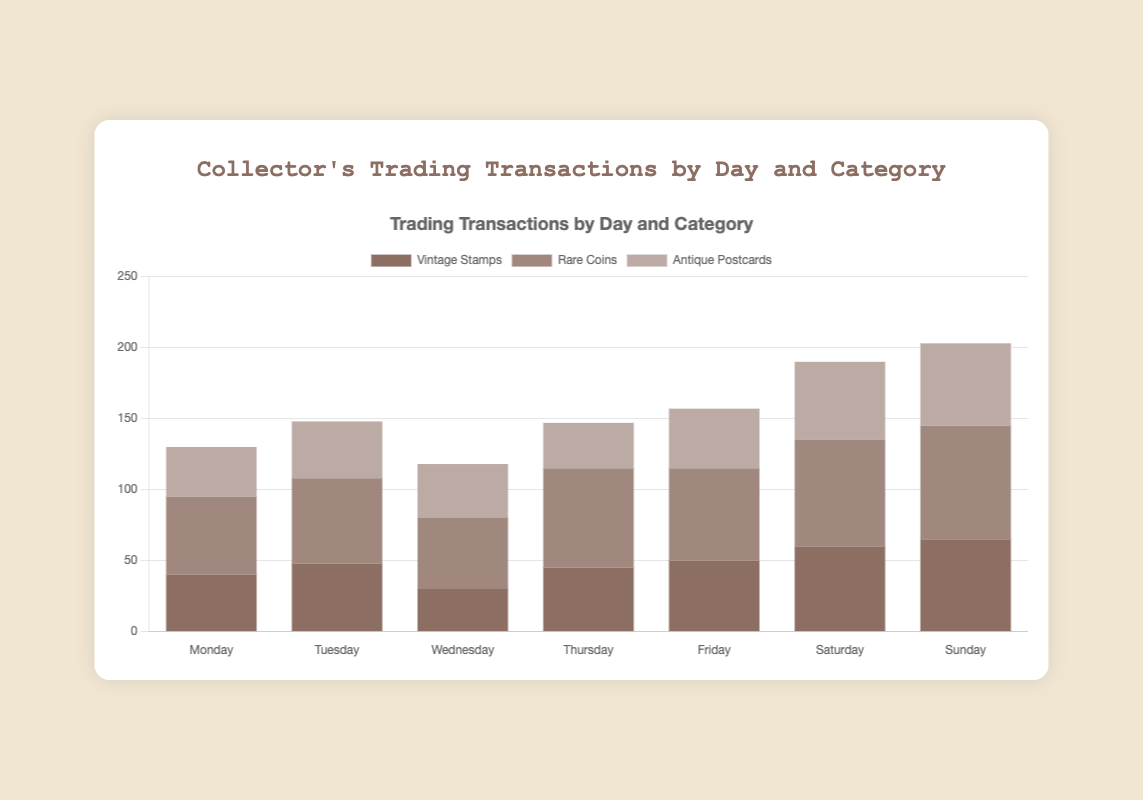Which item category has the highest number of transactions on Sunday? Based on the chart, look for the highest bar in the Sunday column, which corresponds to the "Rare Coins" category.
Answer: Rare Coins Which day has the highest total number of transactions across all categories? Add up transactions by day: (Monday: 40+55+35=130), (Tuesday: 48+60+40=148), (Wednesday: 30+50+38=118), (Thursday: 45+70+32=147), (Friday: 50+65+42=157), (Saturday: 60+75+55=190), (Sunday: 65+80+58=203). Sunday has the highest total.
Answer: Sunday What is the total number of transactions for Vintage Stamps from Monday to Wednesday? Sum the transactions for Vintage Stamps from Monday to Wednesday: (Monday: 40), (Tuesday: 48), (Wednesday: 30). Total is 40+48+30=118.
Answer: 118 On which day is the number of transactions for Antique Postcards the lowest? Identify the smallest bar for Antique Postcards. Transactions are (Monday: 35), (Tuesday: 40), (Wednesday: 38), (Thursday: 32), (Friday: 42), (Saturday: 55), (Sunday: 58). The lowest is on Thursday.
Answer: Thursday How does the number of transactions for Rare Coins on Friday compare to the number on Saturday? Look at the bars for Rare Coins on Friday and Saturday. Friday has 65 transactions, and Saturday has 75 transactions. Thus, Saturday's transactions are more.
Answer: Saturday has more What is the average number of transactions per day for Rare Coins? Calculate the total number of transactions for Rare Coins and divide by 7: (55+60+50+70+65+75+80) = 455. Average is 455/7 ≈ 65.
Answer: 65 Looking at the color coding of the bars, which category has the lightest color? The visual representation shows that "Antique Postcards" has the lightest color among the three categories.
Answer: Antique Postcards What is the total number of transactions on weekdays (Monday to Friday) for Antique Postcards? Add up the transactions from Monday to Friday for Antique Postcards: (Monday: 35), (Tuesday: 40), (Wednesday: 38), (Thursday: 32), (Friday: 42). Total is 35+40+38+32+42=187.
Answer: 187 Which day of the week has the tallest bar for any category, and what is the category? Identify the tallest single bar in the entire chart. The tallest bar is on Sunday for "Rare Coins" with 80 transactions.
Answer: Sunday, Rare Coins 